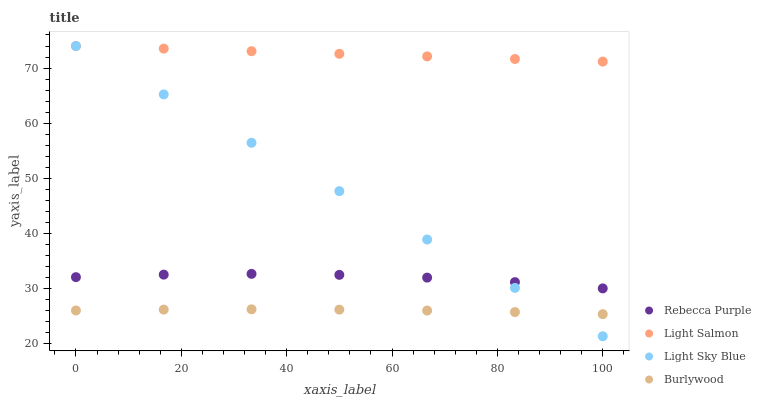Does Burlywood have the minimum area under the curve?
Answer yes or no. Yes. Does Light Salmon have the maximum area under the curve?
Answer yes or no. Yes. Does Light Sky Blue have the minimum area under the curve?
Answer yes or no. No. Does Light Sky Blue have the maximum area under the curve?
Answer yes or no. No. Is Light Sky Blue the smoothest?
Answer yes or no. Yes. Is Rebecca Purple the roughest?
Answer yes or no. Yes. Is Light Salmon the smoothest?
Answer yes or no. No. Is Light Salmon the roughest?
Answer yes or no. No. Does Light Sky Blue have the lowest value?
Answer yes or no. Yes. Does Light Salmon have the lowest value?
Answer yes or no. No. Does Light Sky Blue have the highest value?
Answer yes or no. Yes. Does Rebecca Purple have the highest value?
Answer yes or no. No. Is Burlywood less than Rebecca Purple?
Answer yes or no. Yes. Is Light Salmon greater than Burlywood?
Answer yes or no. Yes. Does Light Sky Blue intersect Rebecca Purple?
Answer yes or no. Yes. Is Light Sky Blue less than Rebecca Purple?
Answer yes or no. No. Is Light Sky Blue greater than Rebecca Purple?
Answer yes or no. No. Does Burlywood intersect Rebecca Purple?
Answer yes or no. No. 